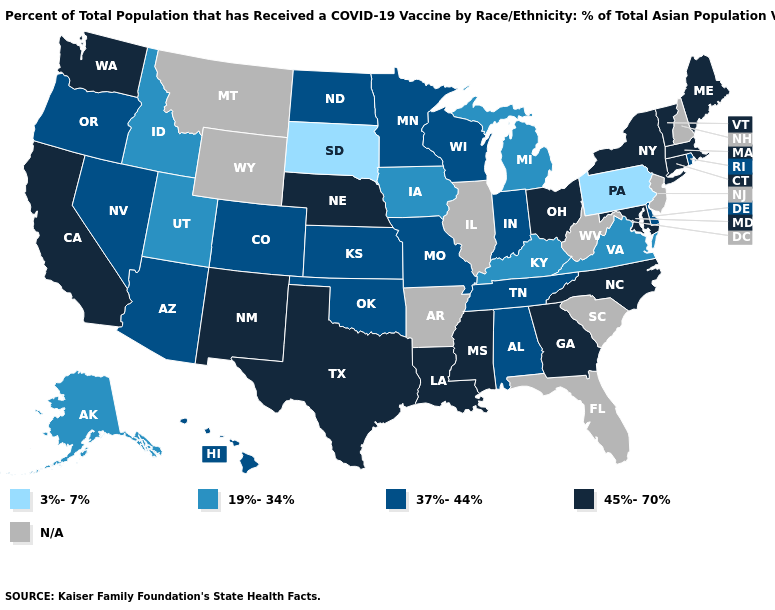Name the states that have a value in the range 19%-34%?
Quick response, please. Alaska, Idaho, Iowa, Kentucky, Michigan, Utah, Virginia. Name the states that have a value in the range 37%-44%?
Keep it brief. Alabama, Arizona, Colorado, Delaware, Hawaii, Indiana, Kansas, Minnesota, Missouri, Nevada, North Dakota, Oklahoma, Oregon, Rhode Island, Tennessee, Wisconsin. Name the states that have a value in the range 45%-70%?
Answer briefly. California, Connecticut, Georgia, Louisiana, Maine, Maryland, Massachusetts, Mississippi, Nebraska, New Mexico, New York, North Carolina, Ohio, Texas, Vermont, Washington. What is the value of Nebraska?
Short answer required. 45%-70%. What is the lowest value in states that border Florida?
Concise answer only. 37%-44%. Among the states that border North Dakota , which have the lowest value?
Answer briefly. South Dakota. What is the value of Vermont?
Write a very short answer. 45%-70%. What is the value of Wisconsin?
Answer briefly. 37%-44%. What is the value of Utah?
Write a very short answer. 19%-34%. What is the highest value in the South ?
Concise answer only. 45%-70%. Which states have the lowest value in the USA?
Give a very brief answer. Pennsylvania, South Dakota. Does the first symbol in the legend represent the smallest category?
Quick response, please. Yes. Does Oklahoma have the lowest value in the South?
Short answer required. No. Does New Mexico have the highest value in the West?
Short answer required. Yes. What is the value of Connecticut?
Quick response, please. 45%-70%. 